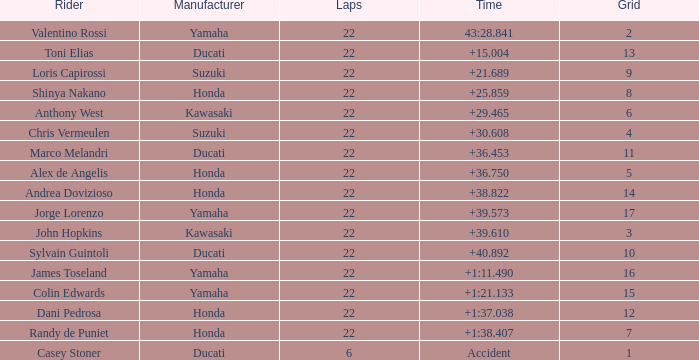What grid is Ducati with fewer than 22 laps? 1.0. 